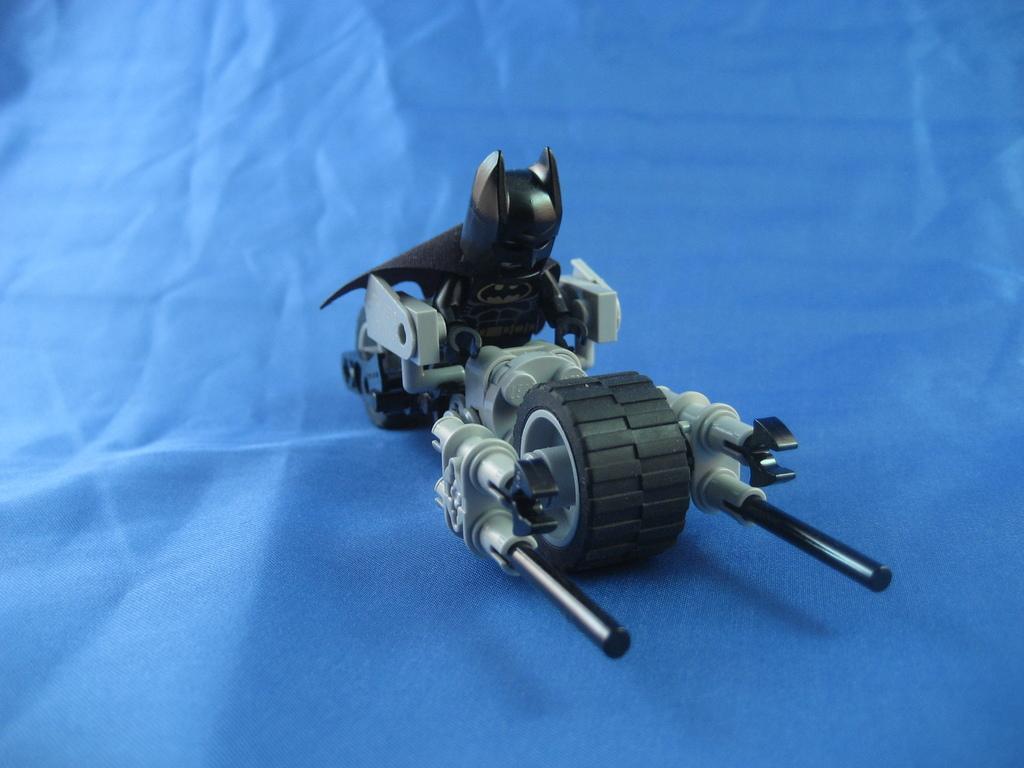Can you describe this image briefly? In this picture I can see a Lego toy of batman and I see the blue color thing. 